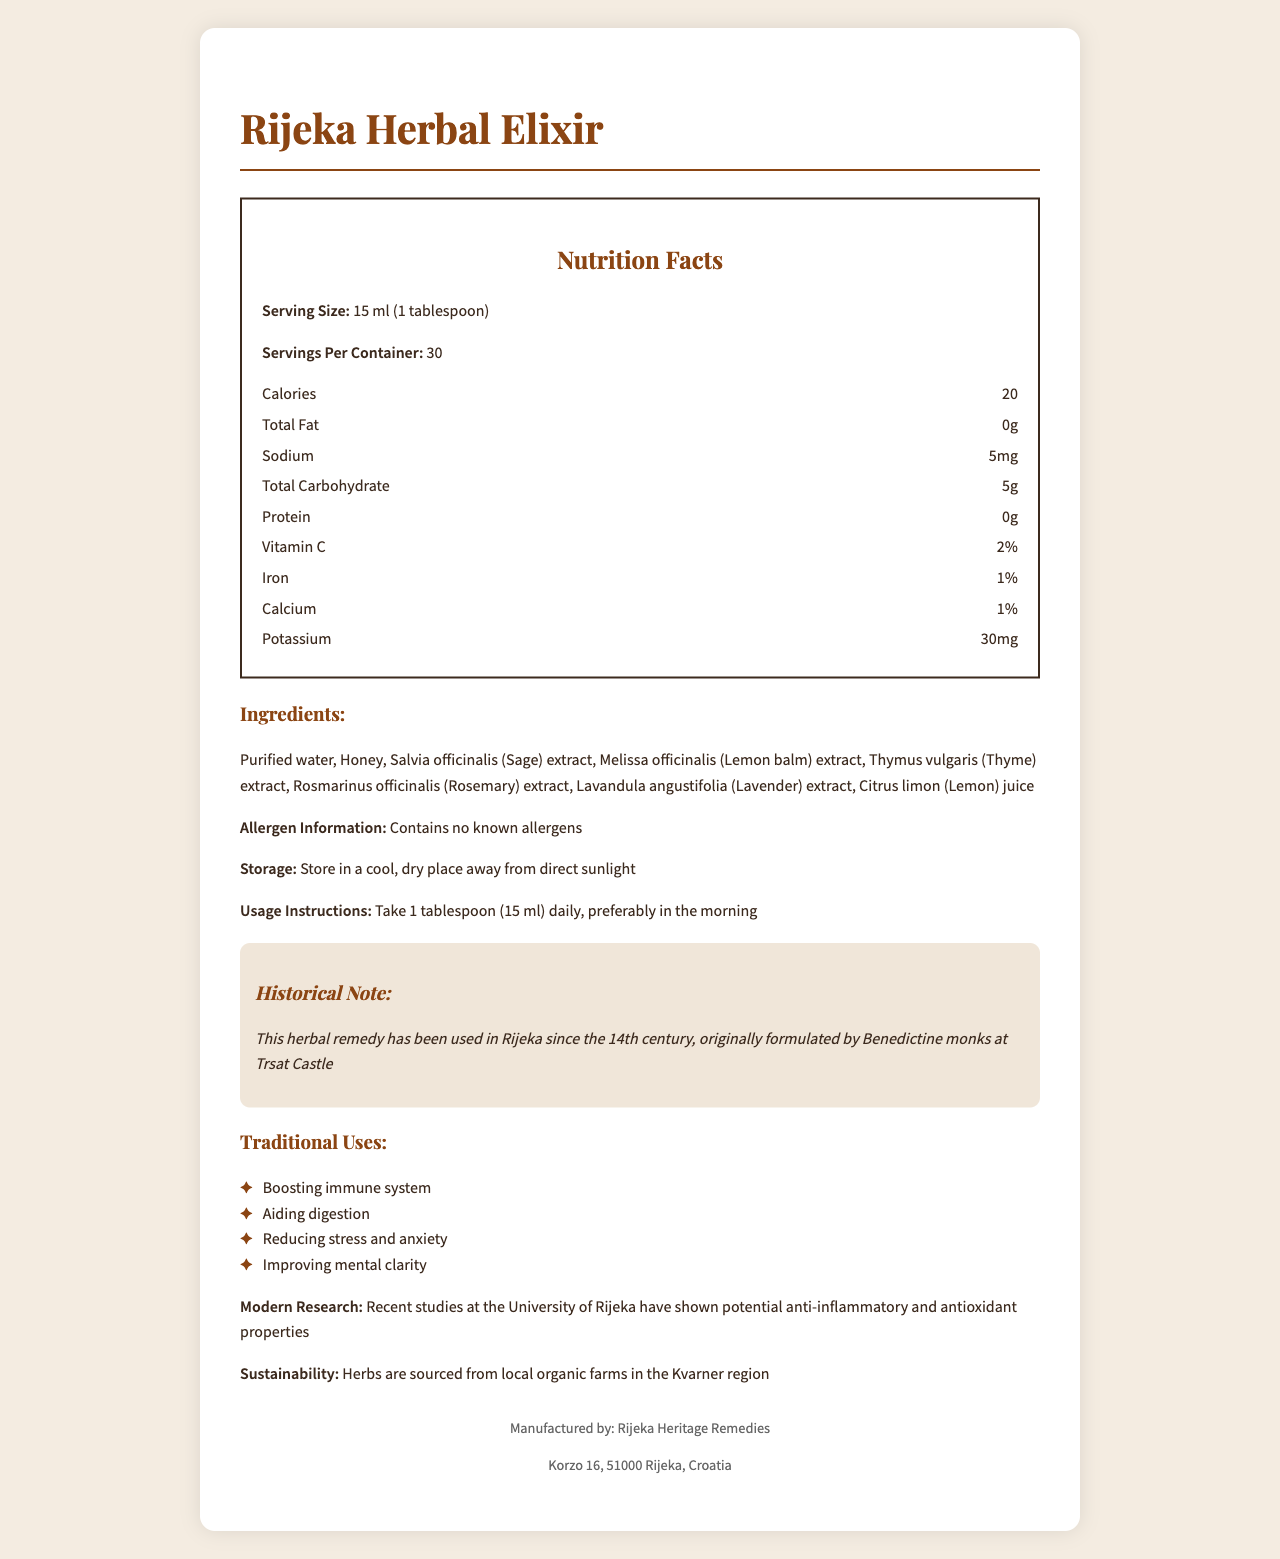what is the product name? The product name is prominently displayed at the top of the document.
Answer: Rijeka Herbal Elixir what is the serving size for the Rijeka Herbal Elixir? The serving size is stated in the Nutrition Facts section as 15 ml (1 tablespoon).
Answer: 15 ml (1 tablespoon) how many calories are in one serving of the elixir? The number of calories per serving is listed as 20 in the Nutrition Facts section.
Answer: 20 what are the main ingredients in the Rijeka Herbal Elixir? The ingredients are listed under the Ingredients section in the document.
Answer: Purified water, Honey, Salvia officinalis (Sage) extract, Melissa officinalis (Lemon balm) extract, Thymus vulgaris (Thyme) extract, Rosmarinus officinalis (Rosemary) extract, Lavandula angustifolia (Lavender) extract, Citrus limon (Lemon) juice what is the sodium content in each serving? The sodium content is listed as 5 mg in the Nutrition Facts section.
Answer: 5 mg what is the purpose of taking the Rijeka Herbal Elixir according to traditional uses? The traditional uses are listed in a bulleted list under the Traditional Uses section.
Answer: Boosting immune system, Aiding digestion, Reducing stress and anxiety, Improving mental clarity how should you store the Rijeka Herbal Elixir? The storage instructions are clearly stated in the document under the Storage section.
Answer: Store in a cool, dry place away from direct sunlight what is the historical significance of the Rijeka Herbal Elixir? The historical significance is highlighted in the Historical Note section.
Answer: This herbal remedy has been used in Rijeka since the 14th century, originally formulated by Benedictine monks at Trsat Castle what is the recommended usage instruction for the elixir? The usage instructions are provided clearly in the document.
Answer: Take 1 tablespoon (15 ml) daily, preferably in the morning Which of the following herbs is NOT listed as an ingredient in the Rijeka Herbal Elixir? 1. Sage 2. Thyme 3. Ginger 4. Lavender Sage, Thyme, and Lavender are listed as ingredients, but Ginger is not mentioned.
Answer: 3. Ginger how many servings are there in one container of the Rijeka Herbal Elixir? A. 15 B. 30 C. 45 D. 60 The document states that there are 30 servings per container.
Answer: B. 30 is there any protein content in each serving of the elixir? The Nutrition Facts section shows that the protein content is 0 grams per serving.
Answer: No Summarize the information provided about the Rijeka Herbal Elixir. This summary combines all major points of the document, including the product's historical background, ingredients, nutritional information, usage instructions, and modern research findings.
Answer: The Rijeka Herbal Elixir is a traditional herbal remedy originating from Rijeka and formulated by Benedictine monks in the 14th century. It is primarily used to boost the immune system, aid digestion, reduce stress and anxiety, and improve mental clarity. The elixir contains ingredients such as purified water, honey, and extracts from sage, lemon balm, thyme, rosemary, lavender, and lemon juice. It has 20 calories per serving, contains minimal fat, sodium, carbohydrates, and protein, and provides small amounts of vitamin C, iron, calcium, and potassium. The elixir should be stored in a cool, dry place, and the recommended intake is 1 tablespoon (15 ml) daily. Recent studies indicate potential anti-inflammatory and antioxidant properties, and all herbs are sourced from local organic farms. what are the results of modern research on the Rijeka Herbal Elixir? The findings from modern research are mentioned towards the end of the document.
Answer: Recent studies at the University of Rijeka have shown potential anti-inflammatory and antioxidant properties where is the manufacturer of the Rijeka Herbal Elixir located? The manufacturer's address is listed at the bottom of the document.
Answer: Korzo 16, 51000 Rijeka, Croatia who formulated the original recipe for the Rijeka Herbal Elixir? The historical note states that the original formulation was created by Benedictine monks at Trsat Castle in the 14th century.
Answer: Benedictine monks at Trsat Castle what is the purpose of using honey in the Rijeka Herbal Elixir? The document lists honey as an ingredient but does not specify its purpose.
Answer: Not enough information 